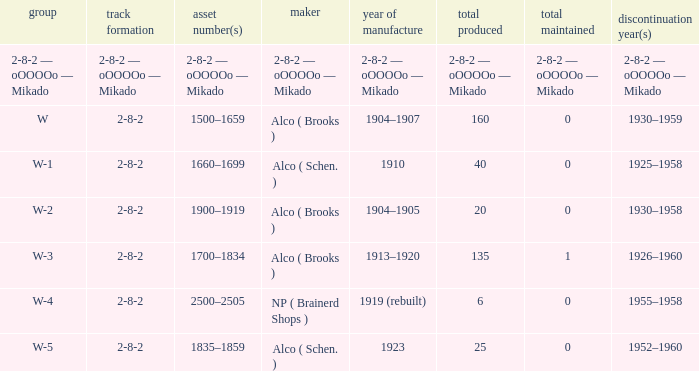Which class had a quantity made of 20? W-2. 